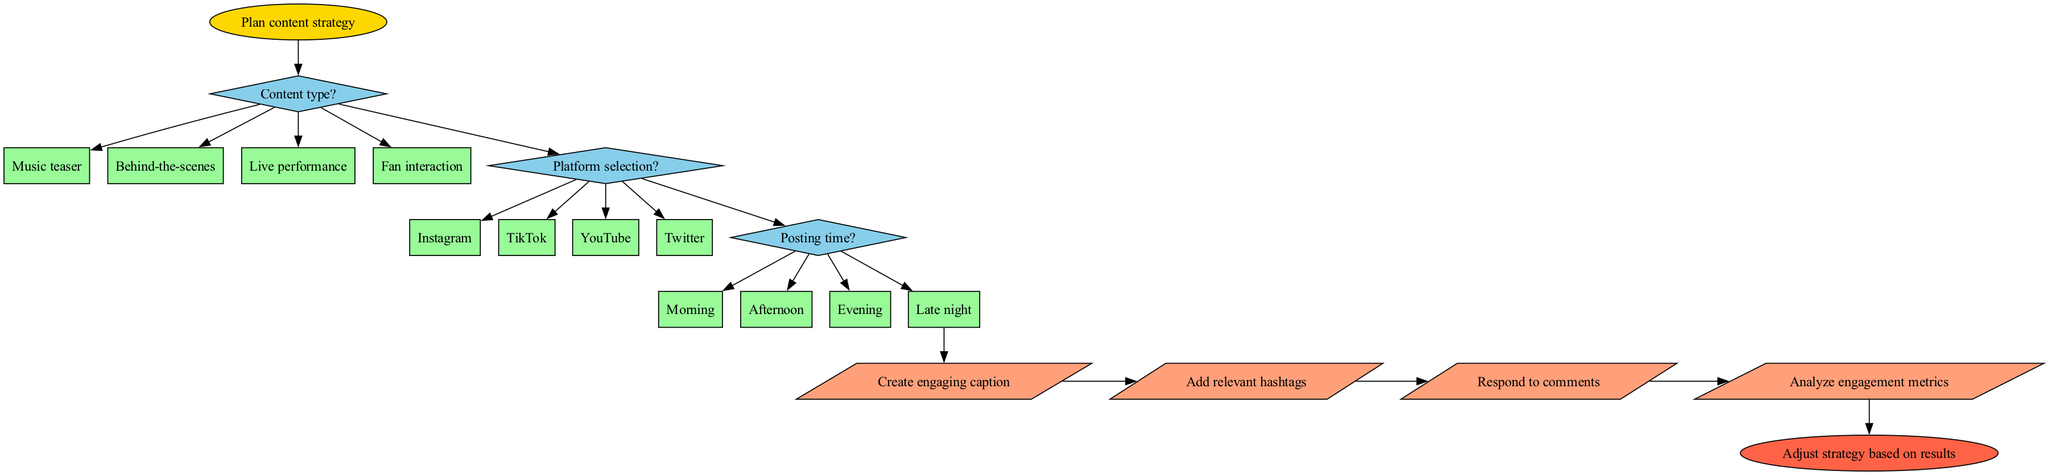What is the first step in the diagram? The first step indicated in the diagram is "Plan content strategy," which is shown as the start node. It's the initial action that the artist should take before moving through the decisions.
Answer: Plan content strategy How many decision nodes are present in the diagram? There are four decision nodes in the diagram: one for content type, one for platform selection, and one for posting time. This totals to three decision points, each leading to options.
Answer: Three What content type option is listed in the second decision node? The options for the second decision node are "Music teaser," "Behind-the-scenes," "Live performance," and "Fan interaction." The second option listed here is "Behind-the-scenes."
Answer: Behind-the-scenes Which action is the last one before reaching the end node? The last action performed before reaching the end node is "Analyze engagement metrics." This action follows all previous actions and concludes the engagement chain in the diagram.
Answer: Analyze engagement metrics What platform is selected if the choice is TikTok? If the choice is "TikTok" from the second decision node, then the path follows that route directly to the next phase of actions without diverging.
Answer: TikTok Which shape is used for decision nodes in the diagram? Decision nodes are represented with diamond shapes in the diagram, indicating that a choice must be made at those points before proceeding.
Answer: Diamond If the posting time selected is "Evening," what follows next? Selecting "Evening" as the posting time leads to the subsequent actions which do not specify any further decisions. This will transition directly into the actions to take after making this decision.
Answer: Actions What color is used for the action nodes in the diagram? The action nodes are filled with a soft salmon color, which helps differentiate them from decision and start nodes.
Answer: Salmon 